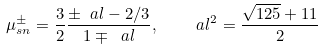Convert formula to latex. <formula><loc_0><loc_0><loc_500><loc_500>\mu _ { s n } ^ { \pm } = \frac { 3 } { 2 } \frac { \pm \ a l - 2 / 3 } { 1 \mp \ a l } , \quad \ a l ^ { 2 } = \frac { \sqrt { 1 2 5 } + 1 1 } 2</formula> 